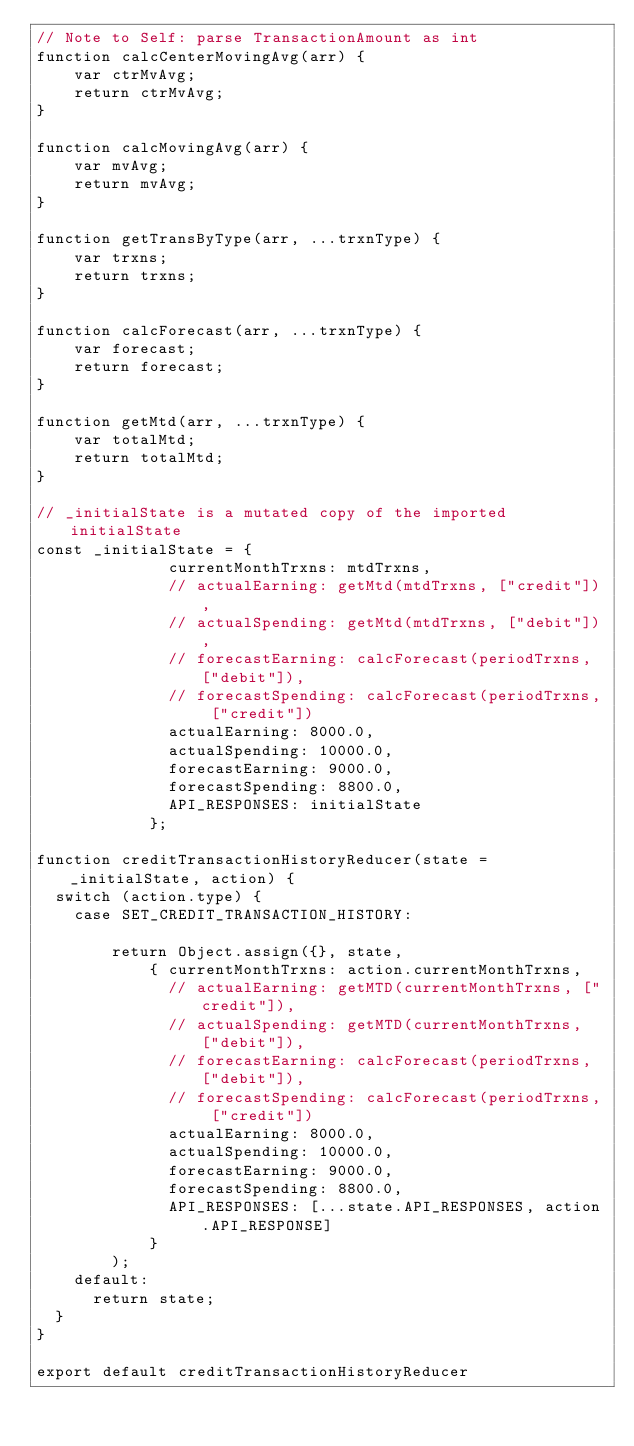Convert code to text. <code><loc_0><loc_0><loc_500><loc_500><_JavaScript_>// Note to Self: parse TransactionAmount as int
function calcCenterMovingAvg(arr) {
    var ctrMvAvg;
    return ctrMvAvg;
}

function calcMovingAvg(arr) {
    var mvAvg;
    return mvAvg;
}

function getTransByType(arr, ...trxnType) {
    var trxns;
    return trxns;
}

function calcForecast(arr, ...trxnType) {
    var forecast;
    return forecast;
}

function getMtd(arr, ...trxnType) {
    var totalMtd;
    return totalMtd;
}

// _initialState is a mutated copy of the imported initialState
const _initialState = {
              currentMonthTrxns: mtdTrxns,
              // actualEarning: getMtd(mtdTrxns, ["credit"]),
              // actualSpending: getMtd(mtdTrxns, ["debit"]),
              // forecastEarning: calcForecast(periodTrxns, ["debit"]),
              // forecastSpending: calcForecast(periodTrxns, ["credit"])
              actualEarning: 8000.0,
              actualSpending: 10000.0,
              forecastEarning: 9000.0,
              forecastSpending: 8800.0,
              API_RESPONSES: initialState
            };

function creditTransactionHistoryReducer(state = _initialState, action) {
  switch (action.type) {
    case SET_CREDIT_TRANSACTION_HISTORY:

        return Object.assign({}, state,
            { currentMonthTrxns: action.currentMonthTrxns,
              // actualEarning: getMTD(currentMonthTrxns, ["credit"]),
              // actualSpending: getMTD(currentMonthTrxns, ["debit"]),
              // forecastEarning: calcForecast(periodTrxns, ["debit"]),
              // forecastSpending: calcForecast(periodTrxns, ["credit"])
              actualEarning: 8000.0,
              actualSpending: 10000.0,
              forecastEarning: 9000.0,
              forecastSpending: 8800.0,
              API_RESPONSES: [...state.API_RESPONSES, action.API_RESPONSE]
            }
        );
    default:
      return state;
  }
}

export default creditTransactionHistoryReducer
</code> 